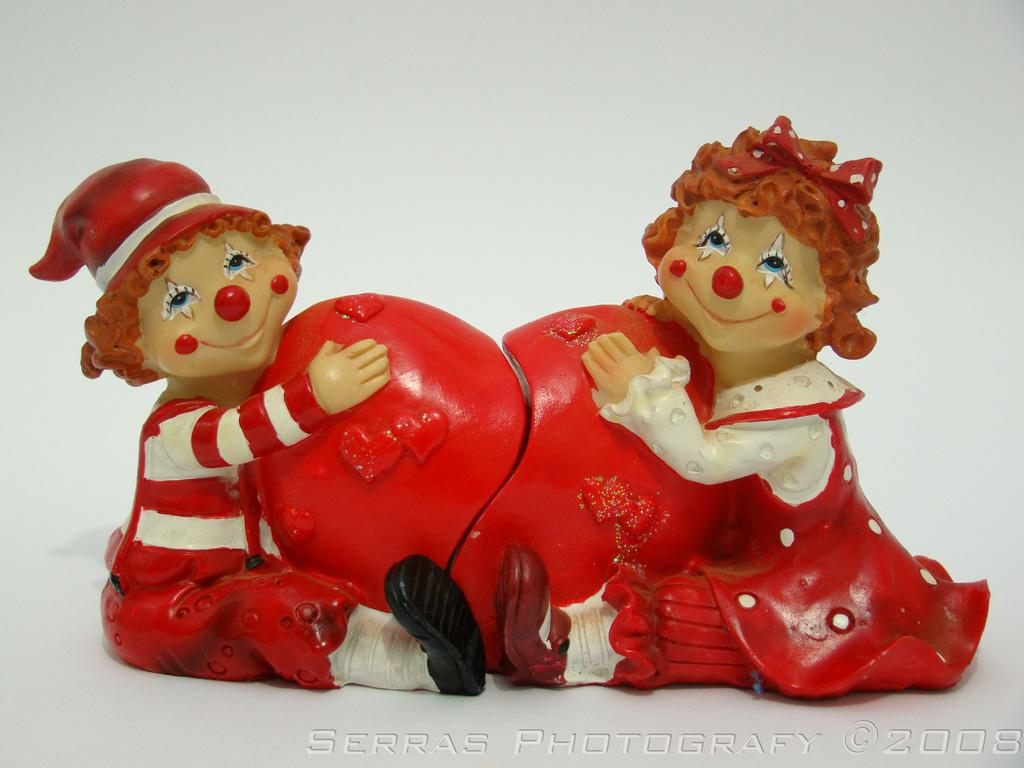How many toys are visible in the image? There are two toys in the image. What colors can be seen on the toys? The toys have white, red, and cream colors. What is the color of the surface and background in the image? The surface and background of the image are white. Is there any text or logo visible in the image? Yes, there is a watermark in the bottom right corner of the image. What type of skirt is the toy wearing in the image? The toys in the image are inanimate objects and do not wear clothing, including skirts. 